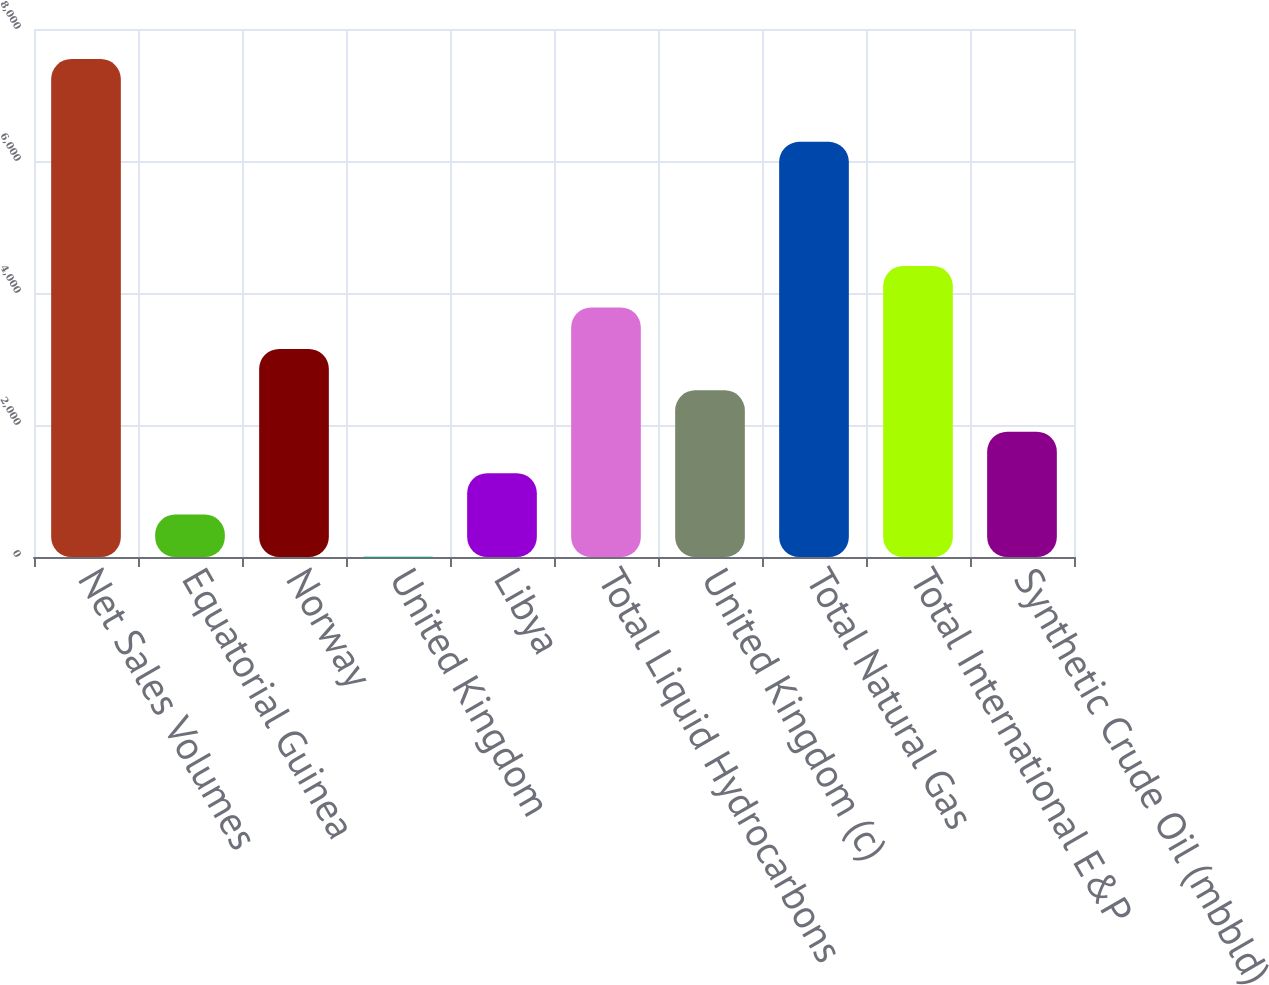Convert chart. <chart><loc_0><loc_0><loc_500><loc_500><bar_chart><fcel>Net Sales Volumes<fcel>Equatorial Guinea<fcel>Norway<fcel>United Kingdom<fcel>Libya<fcel>Total Liquid Hydrocarbons<fcel>United Kingdom (c)<fcel>Total Natural Gas<fcel>Total International E&P<fcel>Synthetic Crude Oil (mbbld)<nl><fcel>7544.8<fcel>643.4<fcel>3153<fcel>16<fcel>1270.8<fcel>3780.4<fcel>2525.6<fcel>6290<fcel>4407.8<fcel>1898.2<nl></chart> 